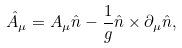<formula> <loc_0><loc_0><loc_500><loc_500>\hat { A } _ { \mu } = A _ { \mu } \hat { n } - \frac { 1 } { g } \hat { n } \times \partial _ { \mu } \hat { n } ,</formula> 